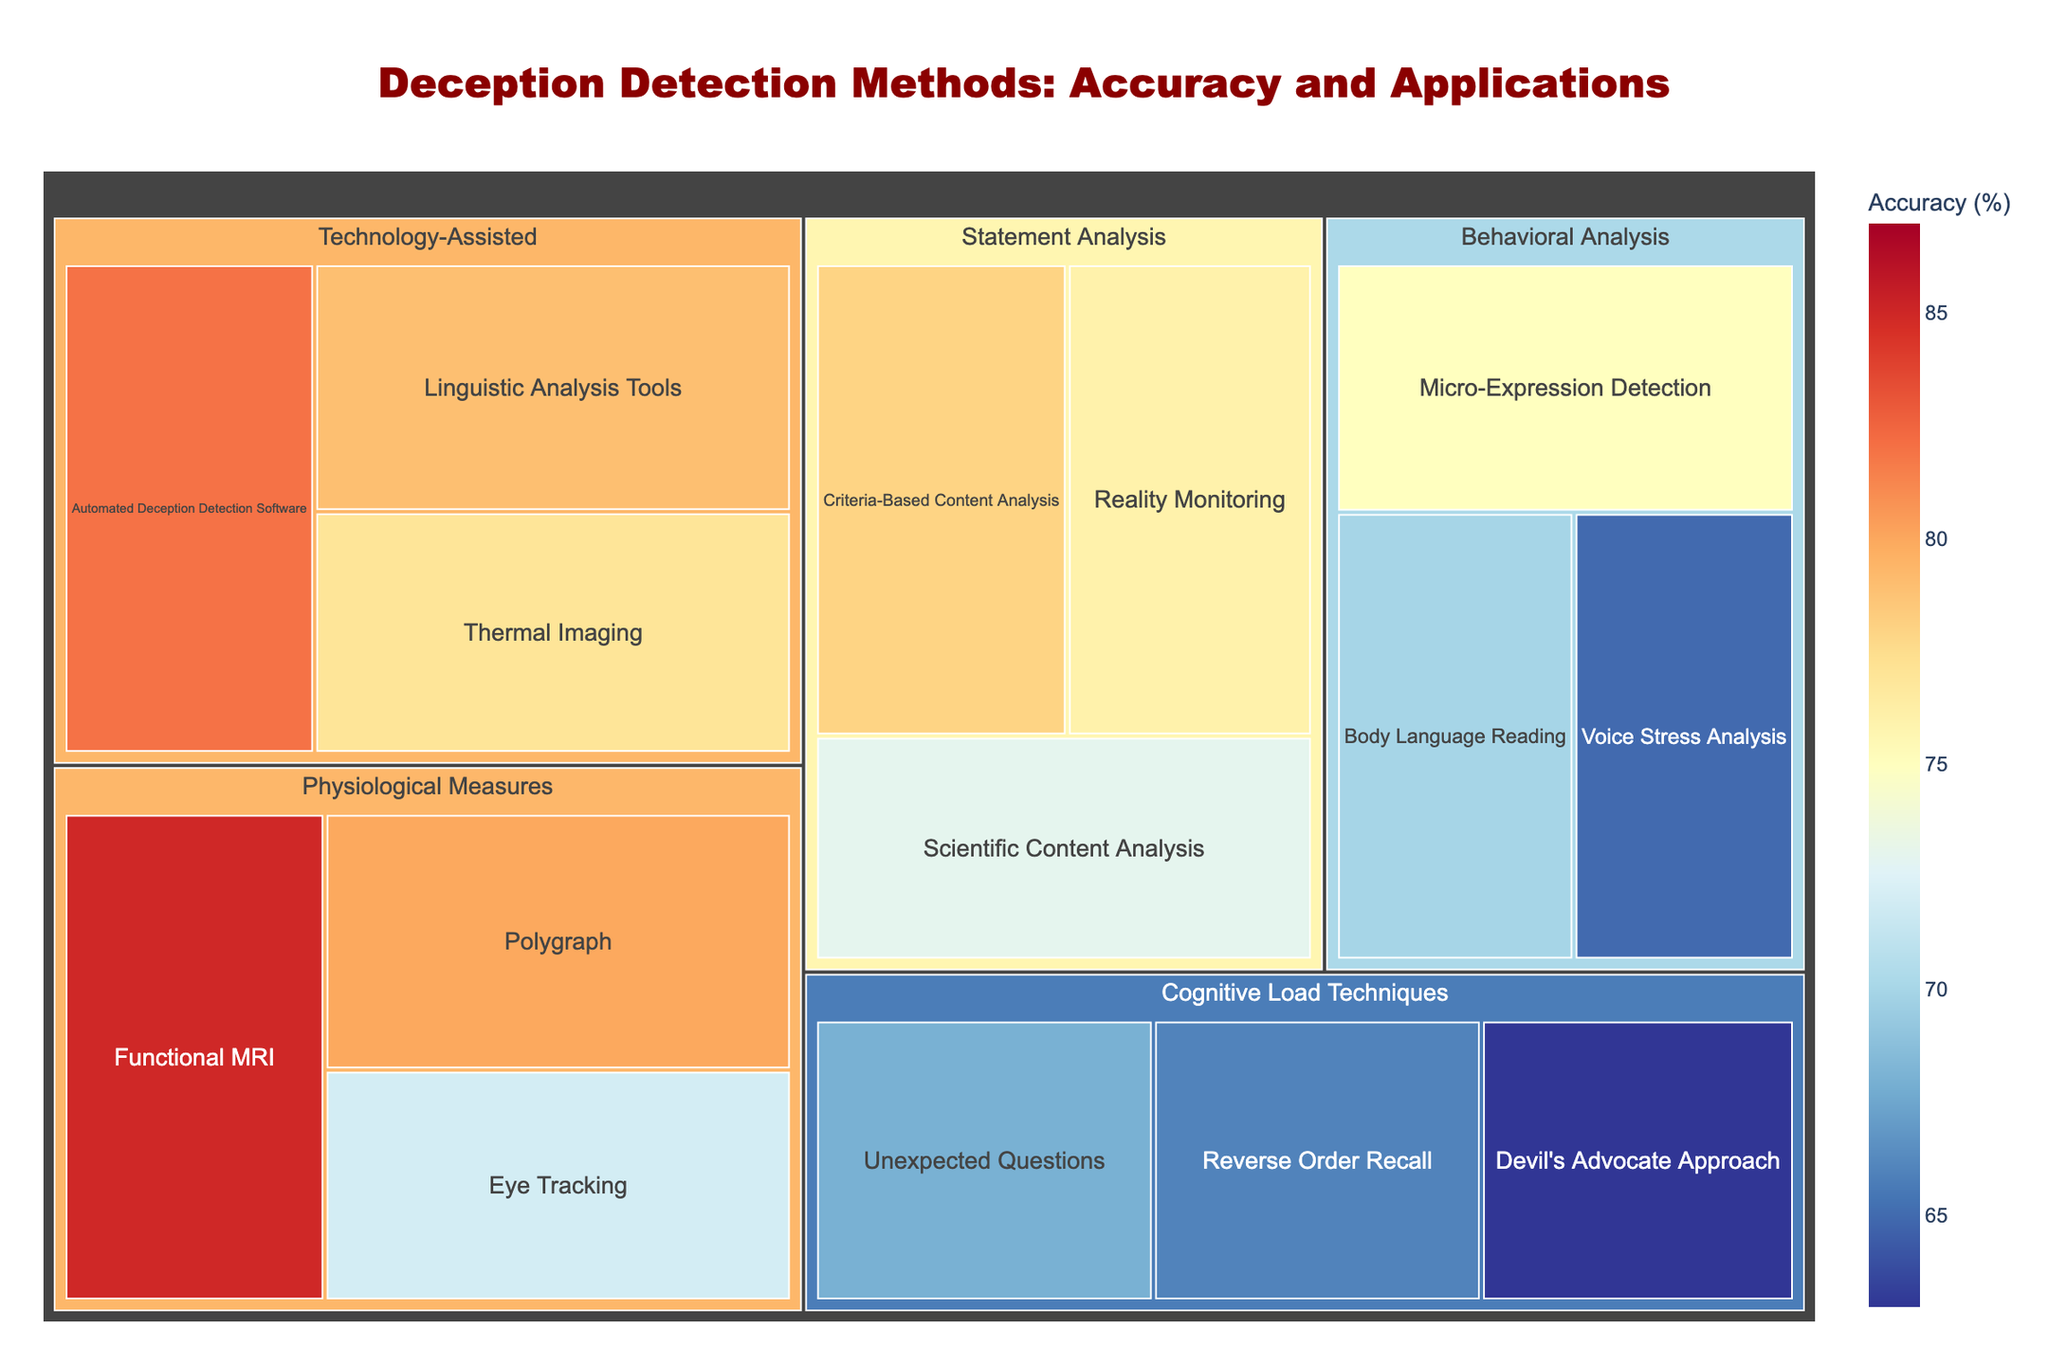what is the title of the figure? The title is generally at the top and formatted to stand out, often in larger and bold text.
Answer: Deception Detection Methods: Accuracy and Applications which method has the highest accuracy? Look for the method with the largest section in the treemap and the highest numerical accuracy value.
Answer: Functional MRI what is the accuracy of the Devil's Advocate Approach? Identify the section labeled 'Devil's Advocate Approach' and read the accuracy value displayed.
Answer: 63% how many categories of deception detection methods are shown? Count the top-level groups labeled in the treemap.
Answer: 5 which method is applied in legal proceedings, and what is its accuracy? Locate the 'Legal Proceedings' application in the hover data and find the associated method and its accuracy.
Answer: Criteria-Based Content Analysis, 78% calculate the average accuracy of the methods under the 'Behavioral Analysis' category. Sum the accuracy of all methods in 'Behavioral Analysis' (75, 70, 65), then divide by the number of methods, which is 3. \( \text{(75 + 70 + 65) / 3 = 70} \)
Answer: 70% compare the accuracy between 'Polygraph' and 'Eye Tracking'. Which is higher and by how much? Identify the accuracy values for both methods (Polygraph - 80, Eye Tracking - 72) and subtract the smaller value from the larger. \( \text{80 - 72 = 8} \)
Answer: Polygraph, by 8% which category has the method with the lowest accuracy, and what is this method? Find the smallest numerical accuracy value and identify its category and method.
Answer: Cognitive Load Techniques, Devil's Advocate Approach how does the accuracy of 'Thermal Imaging' compare to 'Linguistic Analysis Tools'? Retrieve the accuracy values for each (Thermal Imaging - 77, Linguistic Analysis Tools - 79) and compare them.
Answer: Lesser, by 2% what is the sum of the accuracy values for all methods in the 'Technology-Assisted' category? Add all accuracy values in 'Technology-Assisted' (82, 79, 77). \( \text{82 + 79 + 77 = 238} \)
Answer: 238% 